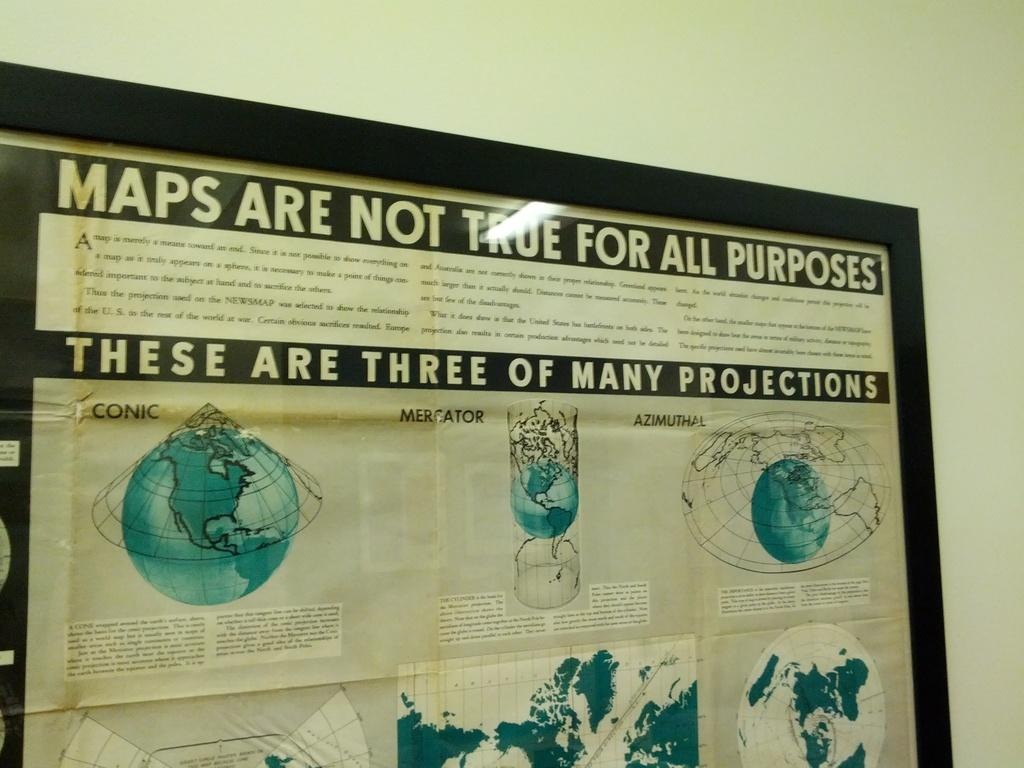<image>
Write a terse but informative summary of the picture. A poster illustrating maps are not true for all purposes they are sometimes only projections. 